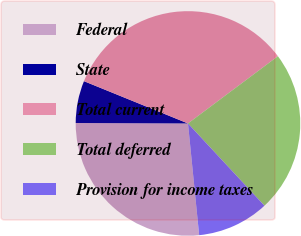<chart> <loc_0><loc_0><loc_500><loc_500><pie_chart><fcel>Federal<fcel>State<fcel>Total current<fcel>Total deferred<fcel>Provision for income taxes<nl><fcel>26.65%<fcel>6.08%<fcel>33.63%<fcel>23.3%<fcel>10.33%<nl></chart> 